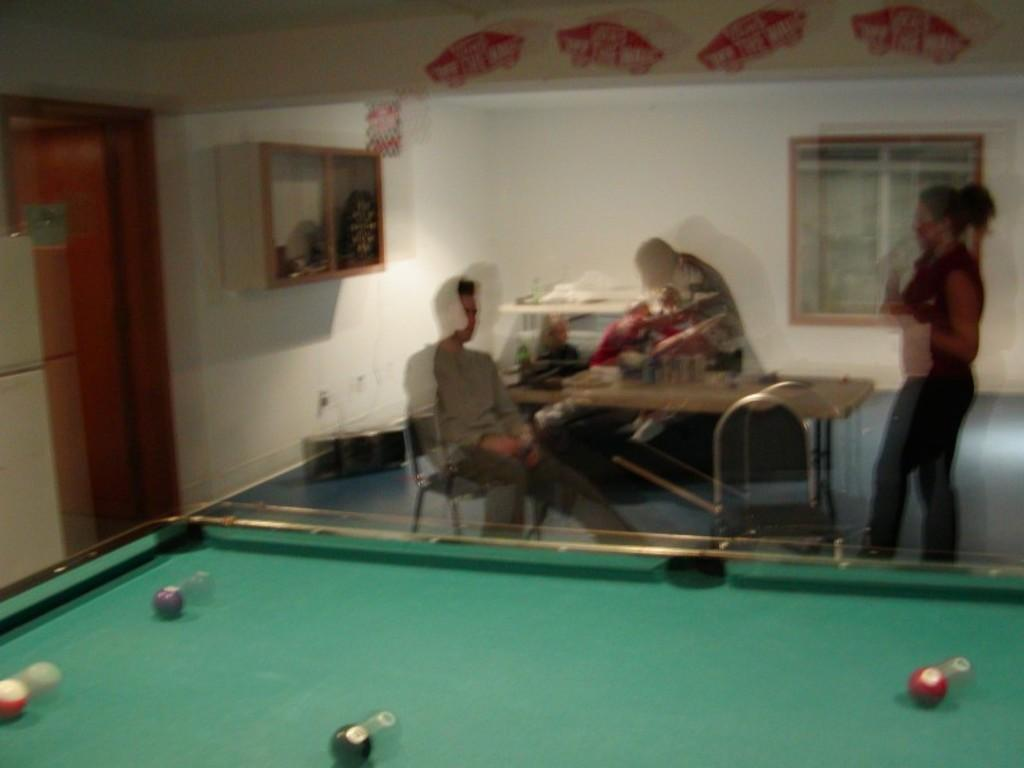What is one of the main features of the room in the image? There is a door in the image. What color is the wall in the room? The wall is white in color. What can be seen in the room that allows natural light to enter? There is a window in the image. What piece of furniture is present in the room for placing objects? There is a table in the image. What type of seating is available in the room? There are chairs in the image. What is the purpose of the board in the image? There is a board in the image, which might be used for writing or displaying information. How many boats are visible in the image? There are no boats present in the image; it features a room with a door, white wall, window, table, chairs, and a board. 